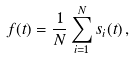Convert formula to latex. <formula><loc_0><loc_0><loc_500><loc_500>f ( t ) = \frac { 1 } { N } \sum _ { i = 1 } ^ { N } s _ { i } ( t ) \, ,</formula> 